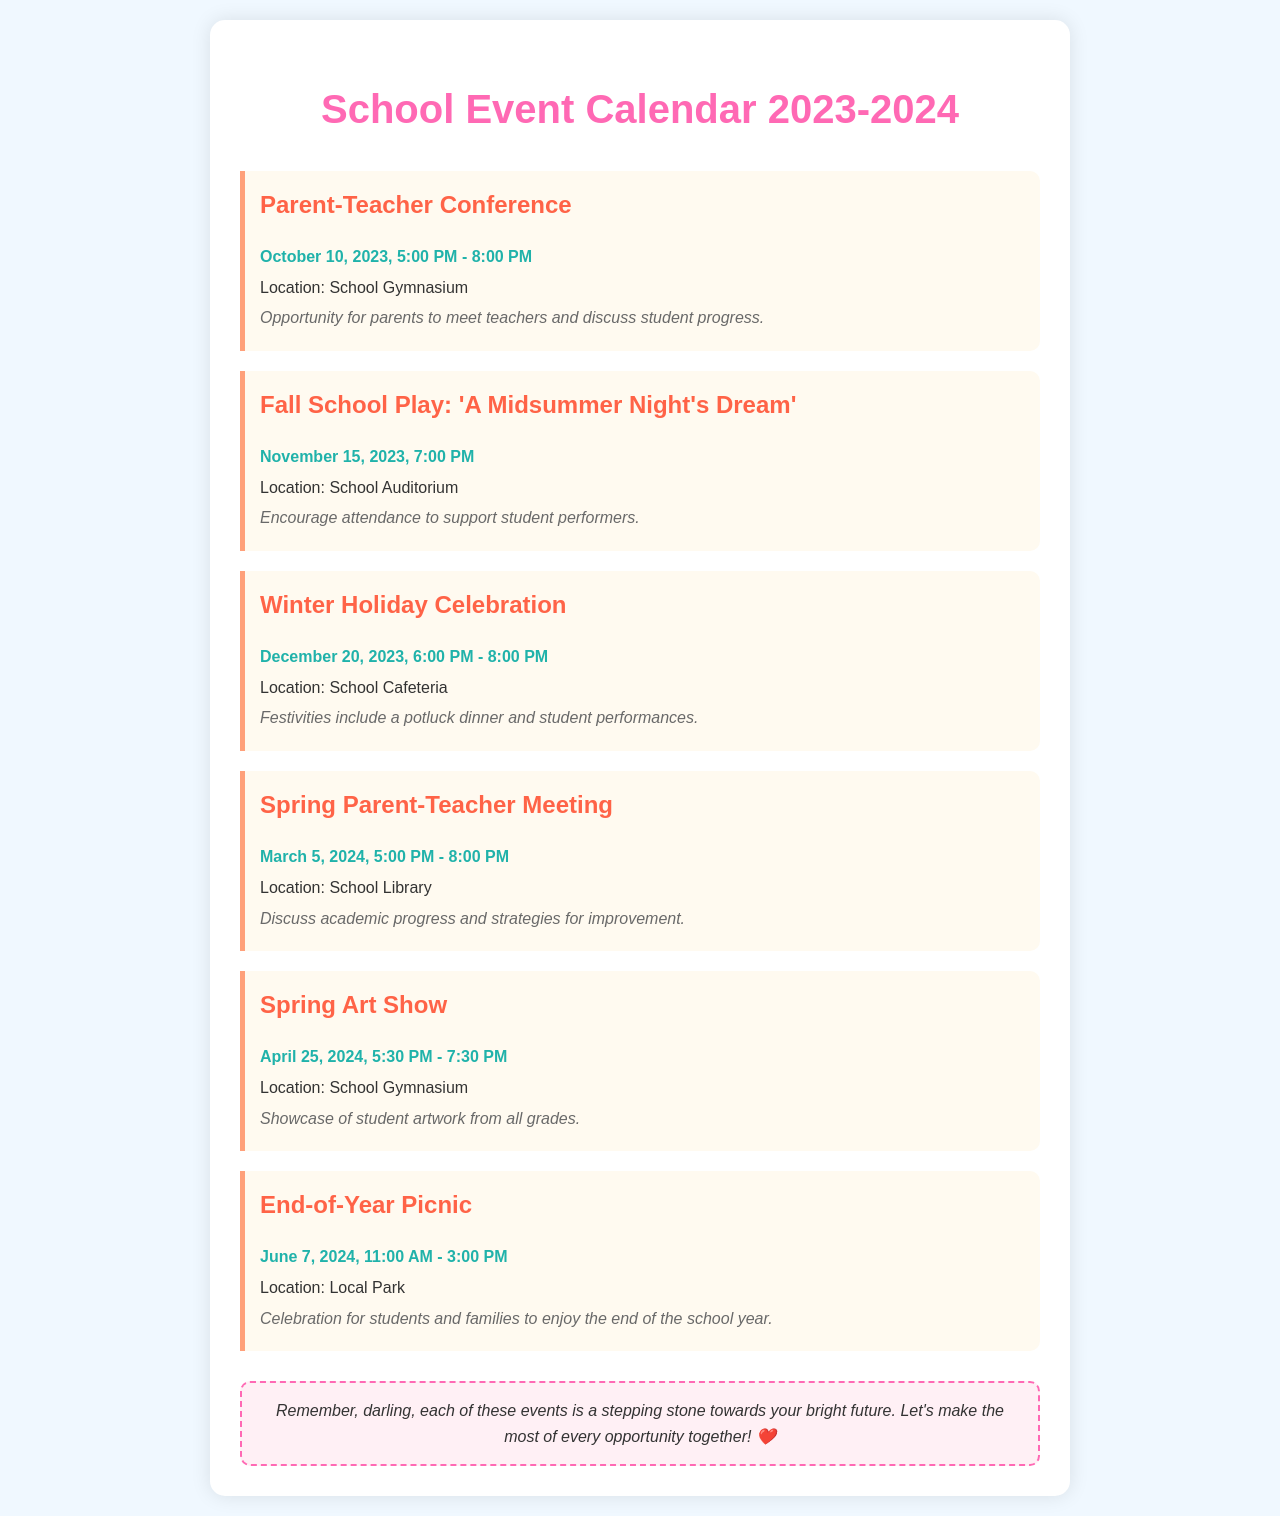What date is the Parent-Teacher Conference? The Parent-Teacher Conference is scheduled for October 10, 2023.
Answer: October 10, 2023 What time does the Winter Holiday Celebration start? The Winter Holiday Celebration starts at 6:00 PM.
Answer: 6:00 PM Where is the Spring Art Show held? The Spring Art Show is held in the School Gymnasium.
Answer: School Gymnasium How many events are scheduled in the document? There are a total of six events listed in the document.
Answer: Six What is the main activity during the End-of-Year Picnic? The End-of-Year Picnic is a celebration for students and families.
Answer: Celebration When is the Fall School Play? The Fall School Play takes place on November 15, 2023.
Answer: November 15, 2023 What type of event is scheduled for March 5, 2024? The event scheduled for March 5, 2024, is a Spring Parent-Teacher Meeting.
Answer: Spring Parent-Teacher Meeting What kind of performances are featured at the Winter Holiday Celebration? The Winter Holiday Celebration includes student performances.
Answer: Student performances 